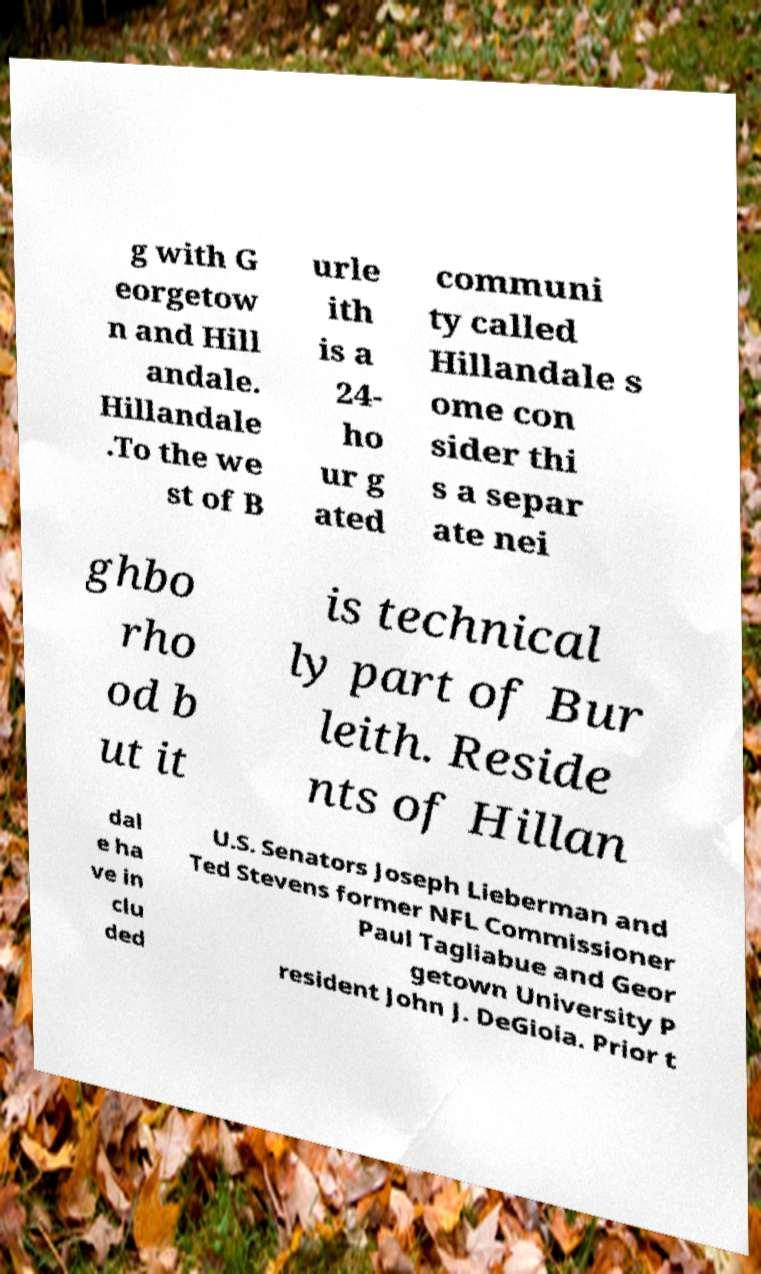Can you read and provide the text displayed in the image?This photo seems to have some interesting text. Can you extract and type it out for me? g with G eorgetow n and Hill andale. Hillandale .To the we st of B urle ith is a 24- ho ur g ated communi ty called Hillandale s ome con sider thi s a separ ate nei ghbo rho od b ut it is technical ly part of Bur leith. Reside nts of Hillan dal e ha ve in clu ded U.S. Senators Joseph Lieberman and Ted Stevens former NFL Commissioner Paul Tagliabue and Geor getown University P resident John J. DeGioia. Prior t 